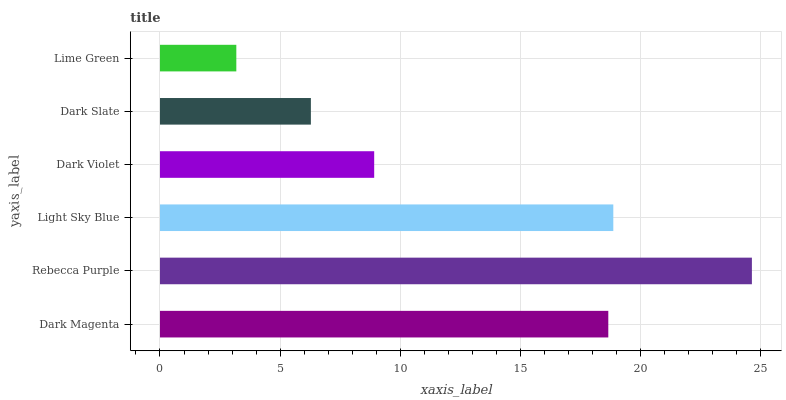Is Lime Green the minimum?
Answer yes or no. Yes. Is Rebecca Purple the maximum?
Answer yes or no. Yes. Is Light Sky Blue the minimum?
Answer yes or no. No. Is Light Sky Blue the maximum?
Answer yes or no. No. Is Rebecca Purple greater than Light Sky Blue?
Answer yes or no. Yes. Is Light Sky Blue less than Rebecca Purple?
Answer yes or no. Yes. Is Light Sky Blue greater than Rebecca Purple?
Answer yes or no. No. Is Rebecca Purple less than Light Sky Blue?
Answer yes or no. No. Is Dark Magenta the high median?
Answer yes or no. Yes. Is Dark Violet the low median?
Answer yes or no. Yes. Is Lime Green the high median?
Answer yes or no. No. Is Dark Magenta the low median?
Answer yes or no. No. 